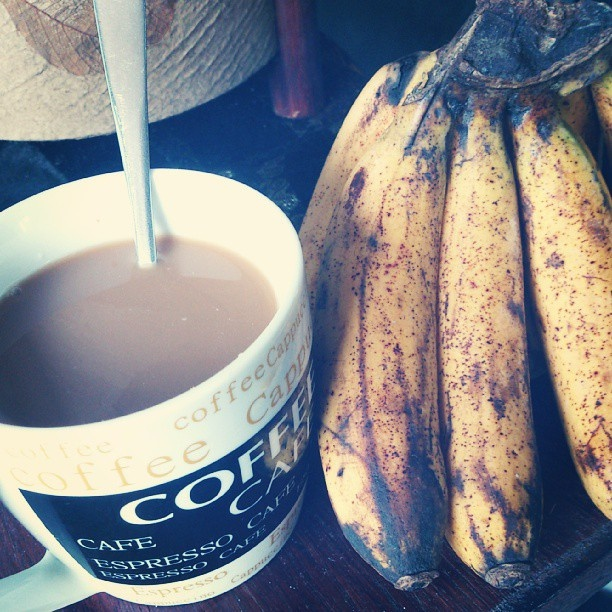Describe the objects in this image and their specific colors. I can see banana in tan, gray, and navy tones, cup in tan, beige, darkgray, navy, and darkblue tones, dining table in tan, navy, darkblue, and blue tones, and spoon in tan, beige, darkgray, lightblue, and gray tones in this image. 